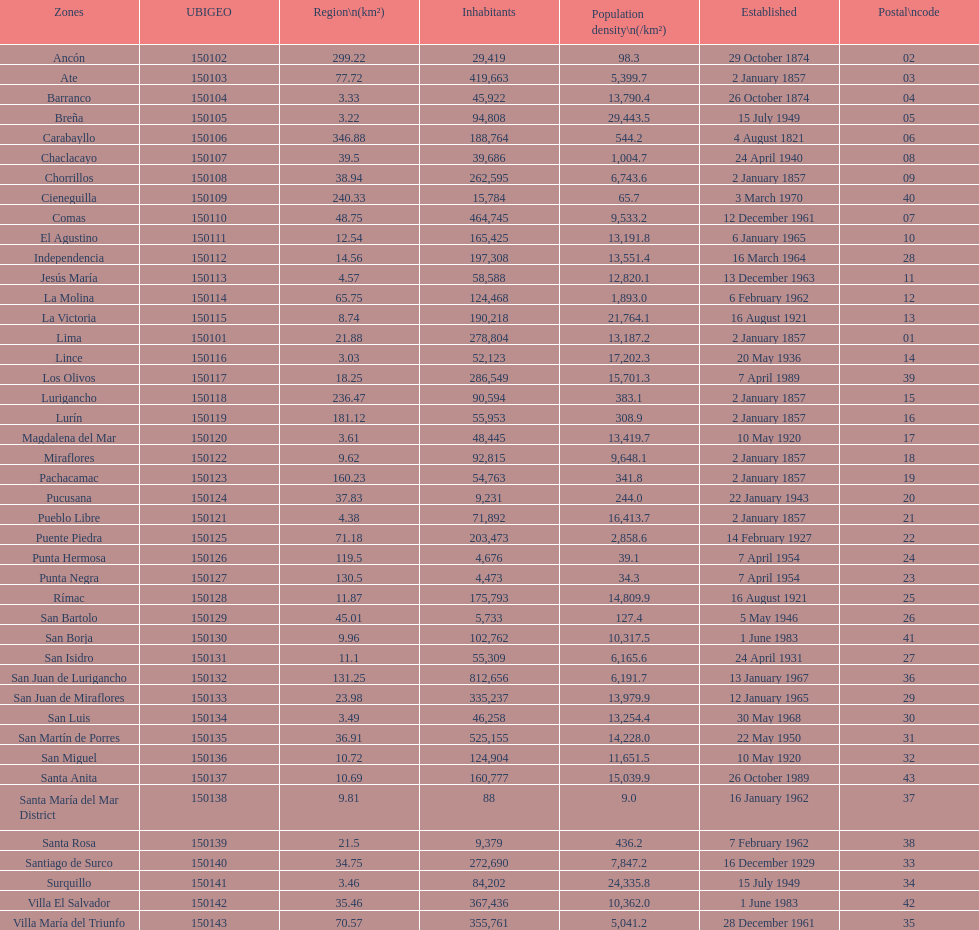What is the total number of districts of lima? 43. 